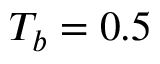<formula> <loc_0><loc_0><loc_500><loc_500>T _ { b } = 0 . 5</formula> 